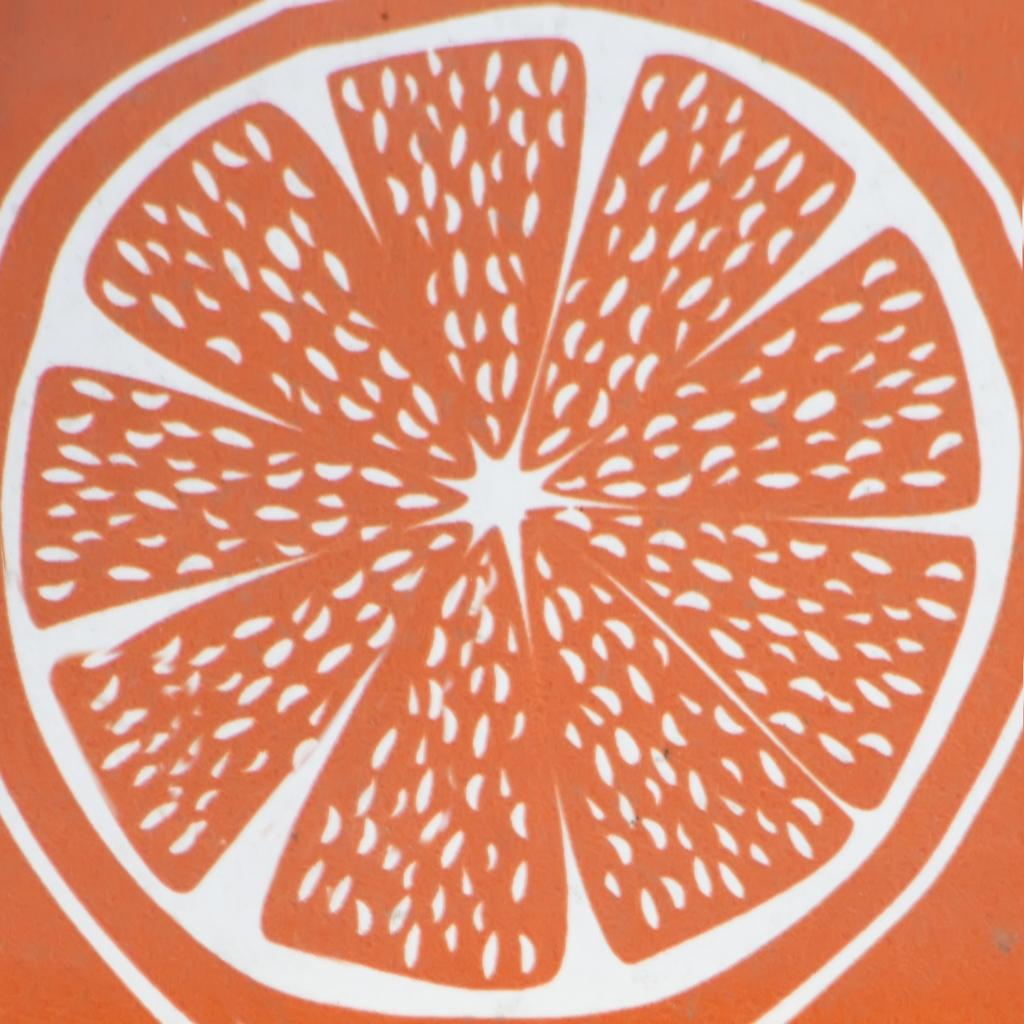What type of image is depicted in the given image? The image is a painted image. What is the main subject of the painted image? There is a fruit depicted in the image. What is the color of the fruit in the image? The fruit is in orange color. Can you see any wilderness or cannon in the painted image? No, there is no wilderness or cannon present in the painted image. How many ladybugs are on the fruit in the image? There are no ladybugs depicted on the fruit in the image. 